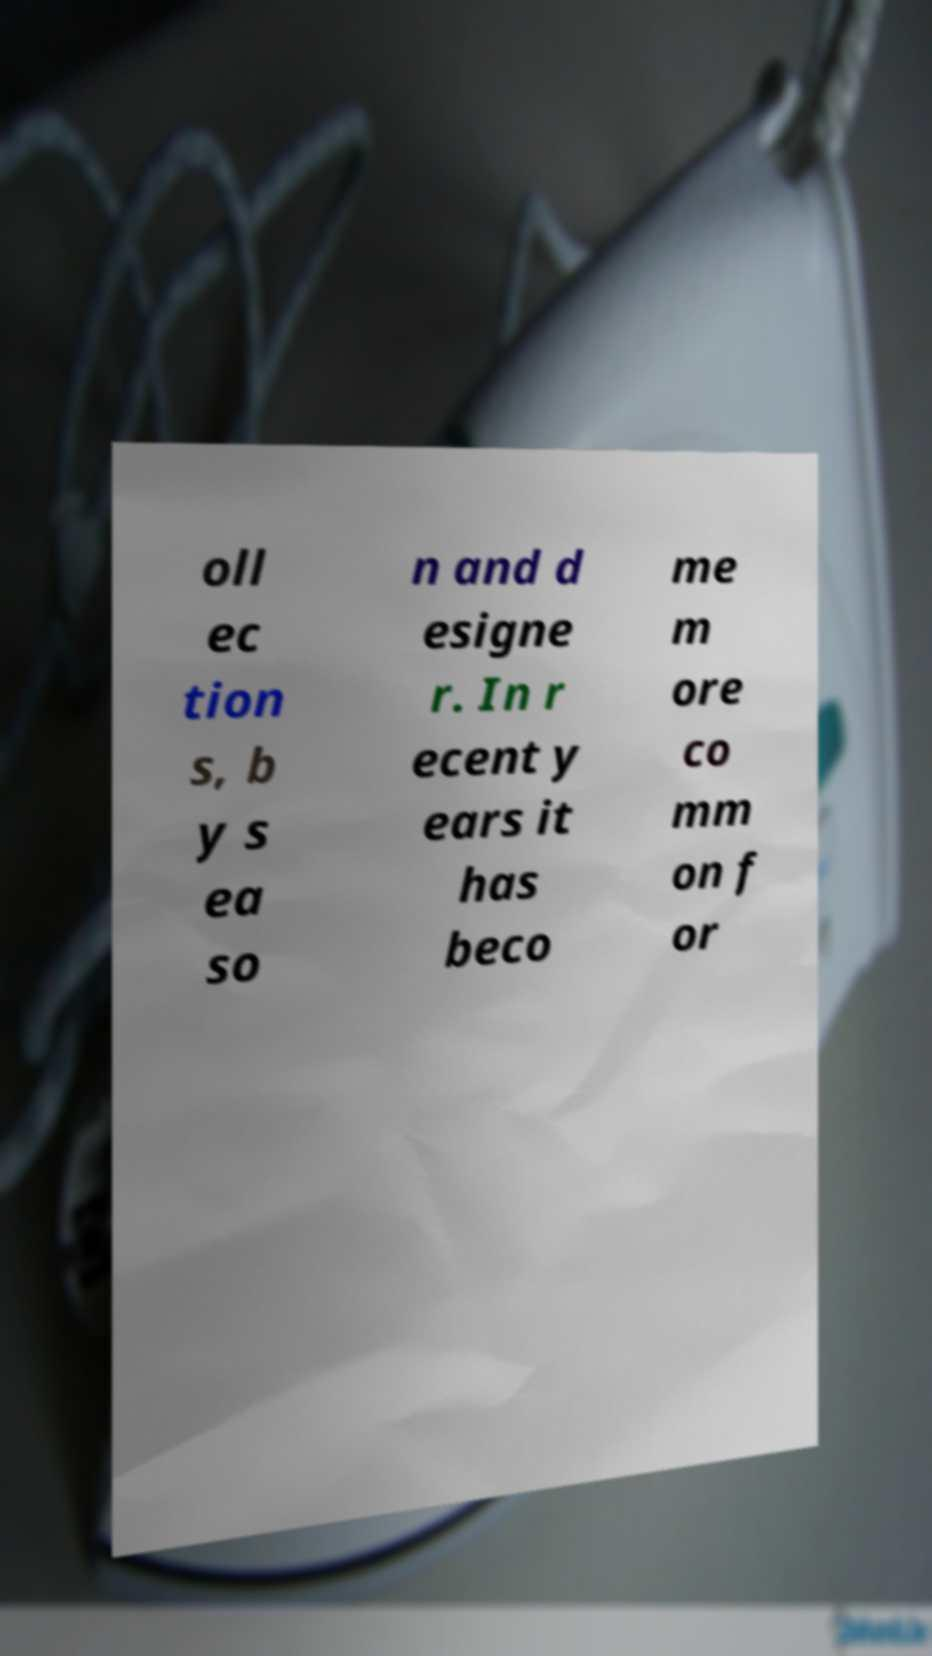Can you accurately transcribe the text from the provided image for me? oll ec tion s, b y s ea so n and d esigne r. In r ecent y ears it has beco me m ore co mm on f or 